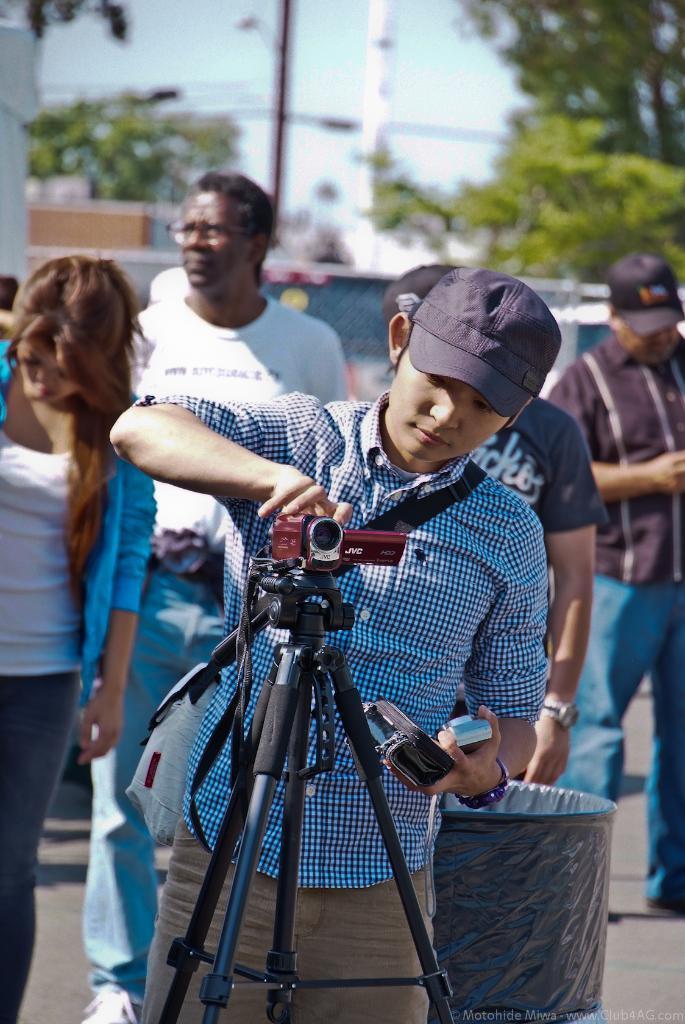How would you summarize this image in a sentence or two? In this picture I can see there is a man standing and he is holding cameras and in the backdrop, there are few people walking and there is a dustbin, there is a building at left, there are trees and poles. The sky is clear. 